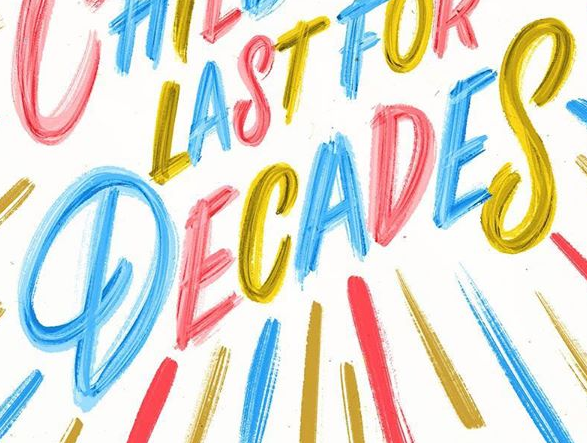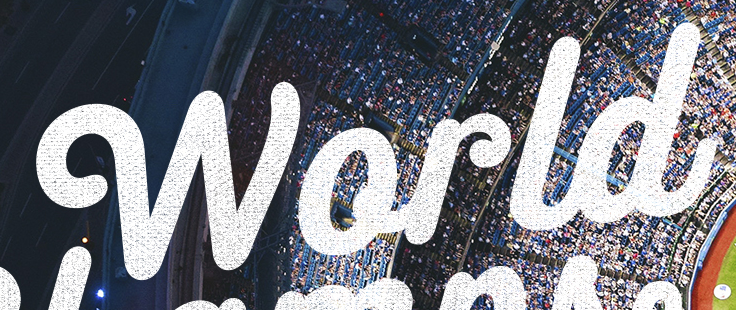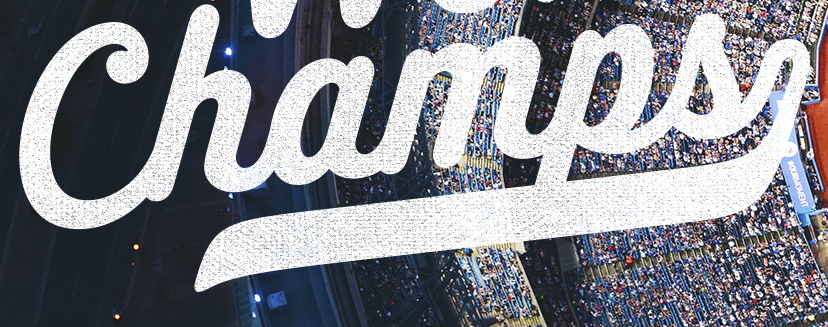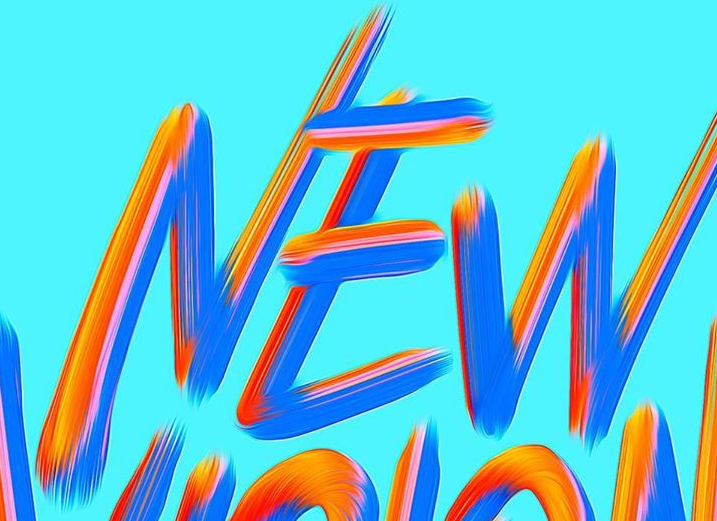Transcribe the words shown in these images in order, separated by a semicolon. DECADES; World; Champs; NEW 